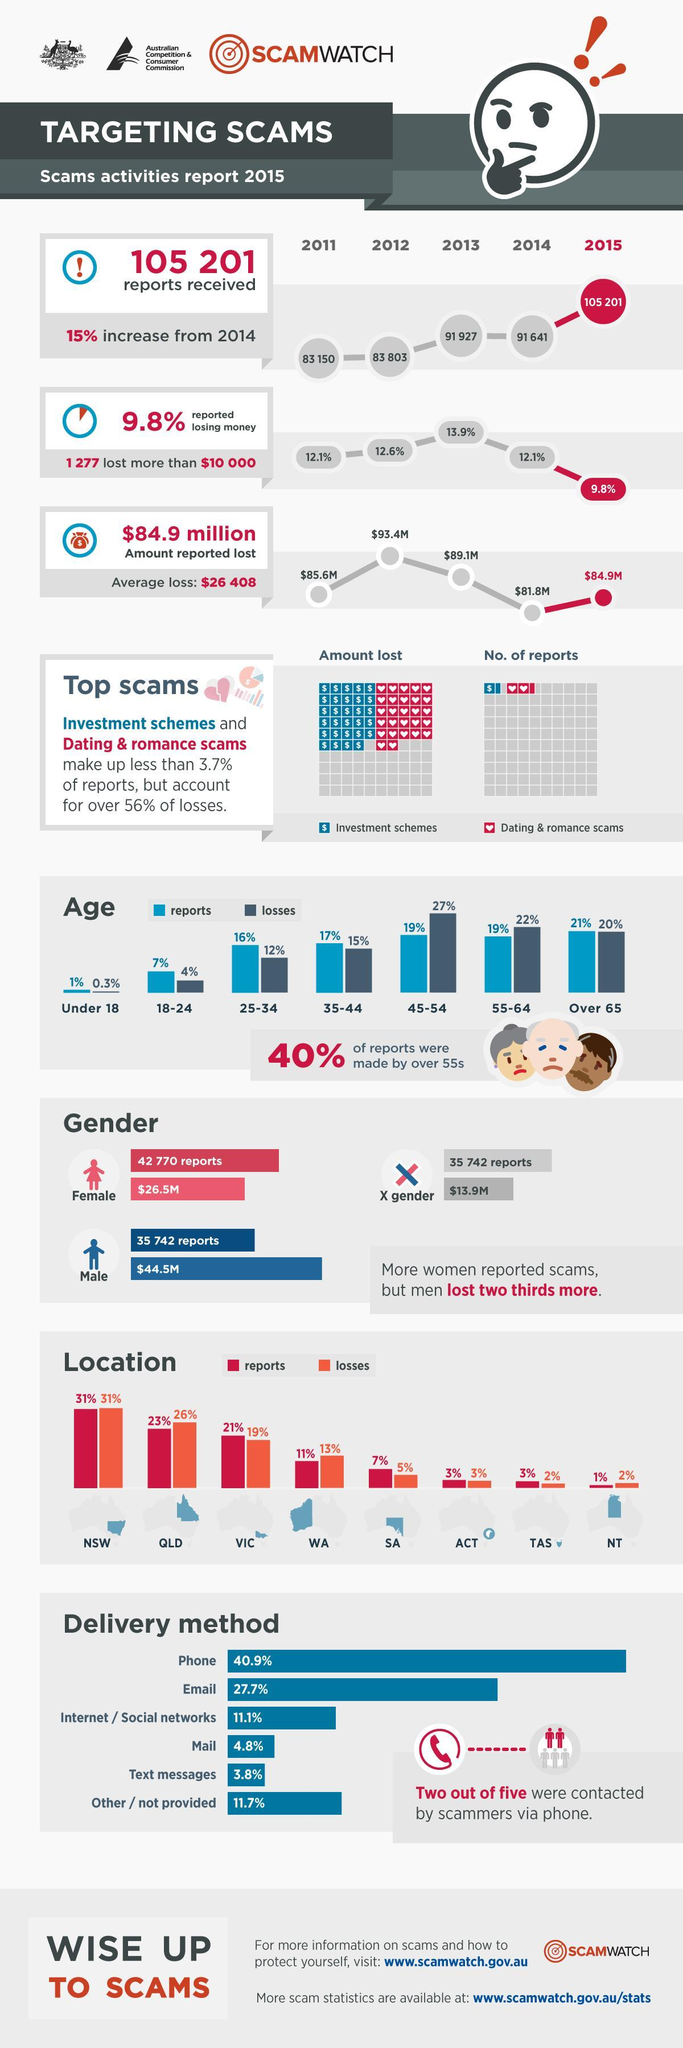Which type of scam had a larger amount of reported cases?
Answer the question with a short phrase. Dating & Romance Scam What was the difference in number of scams reported by women and men? 7,082 Which type of scam had contributed to a higher amount of lost? Investment schemes Which had year reported the highest amount lost? 2012 Which year recorded the highest increase in scams from the year 2011-2015? 2015 Which regions in Australia had an equal percentage of reports and losses? NSW, ACT Which age group had the highest reported losses due to scams? 45-54 What percentage of people aged 45-64 were reporting scams? 19% Which age group reported the highest percentage of scam? Over 65 What was the lowest percentage of money lost from the period 2011-2015? 9.8% 